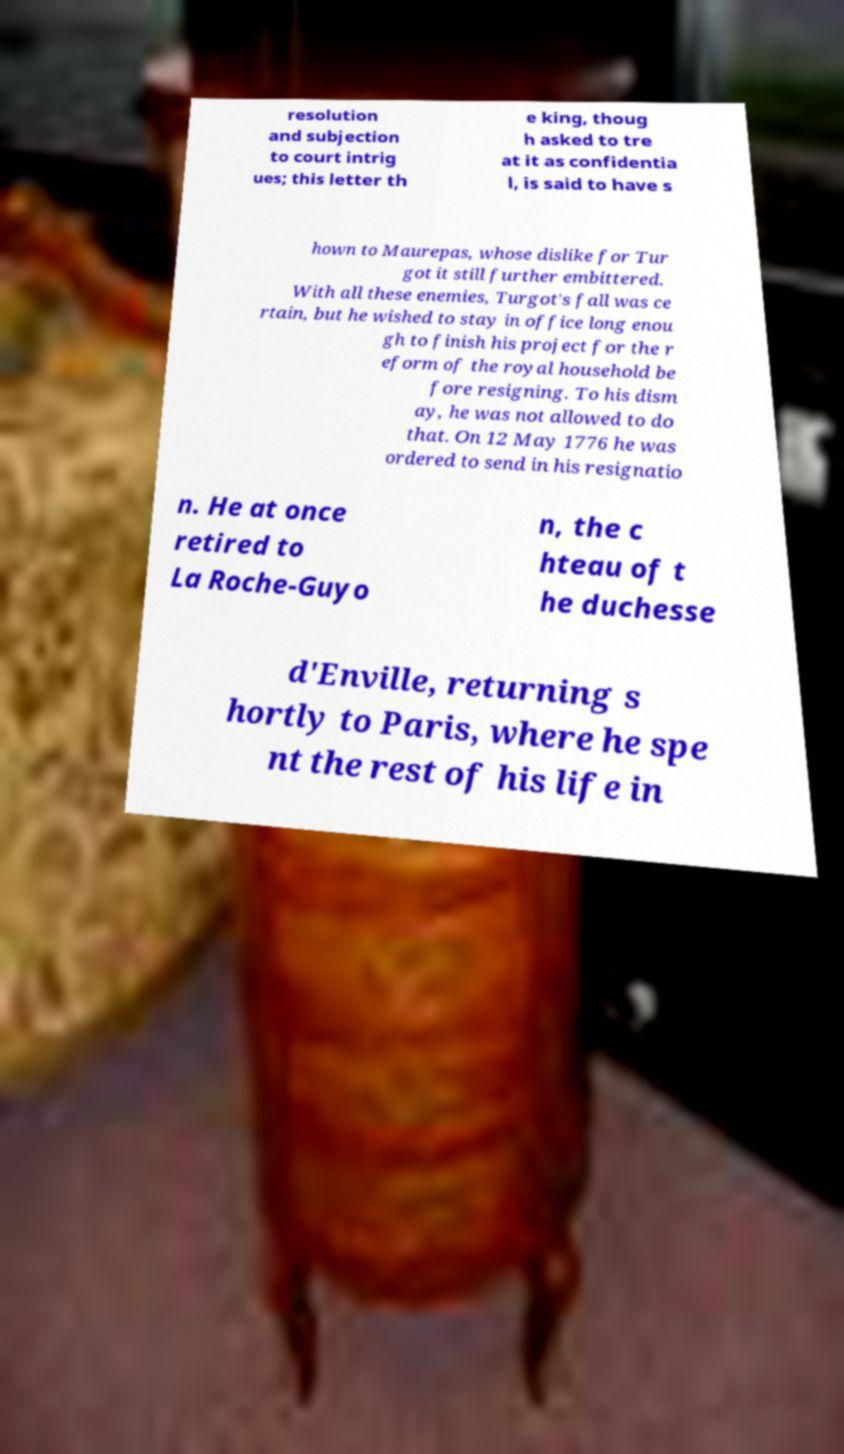I need the written content from this picture converted into text. Can you do that? resolution and subjection to court intrig ues; this letter th e king, thoug h asked to tre at it as confidentia l, is said to have s hown to Maurepas, whose dislike for Tur got it still further embittered. With all these enemies, Turgot's fall was ce rtain, but he wished to stay in office long enou gh to finish his project for the r eform of the royal household be fore resigning. To his dism ay, he was not allowed to do that. On 12 May 1776 he was ordered to send in his resignatio n. He at once retired to La Roche-Guyo n, the c hteau of t he duchesse d'Enville, returning s hortly to Paris, where he spe nt the rest of his life in 